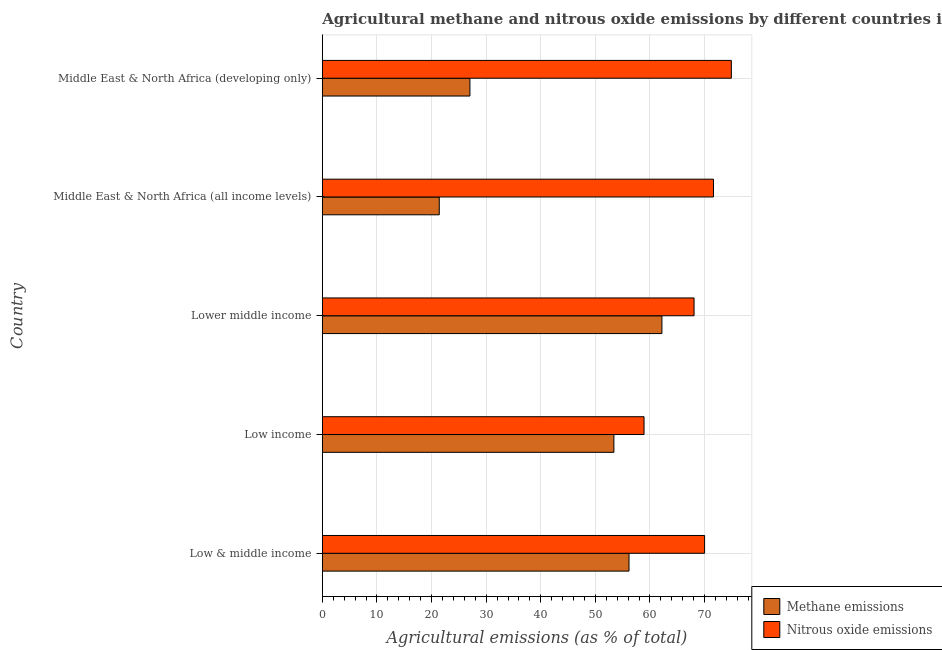How many groups of bars are there?
Provide a succinct answer. 5. How many bars are there on the 5th tick from the top?
Give a very brief answer. 2. How many bars are there on the 1st tick from the bottom?
Make the answer very short. 2. What is the label of the 4th group of bars from the top?
Ensure brevity in your answer.  Low income. What is the amount of methane emissions in Middle East & North Africa (all income levels)?
Provide a short and direct response. 21.41. Across all countries, what is the maximum amount of nitrous oxide emissions?
Offer a terse response. 74.9. Across all countries, what is the minimum amount of nitrous oxide emissions?
Your response must be concise. 58.91. In which country was the amount of nitrous oxide emissions maximum?
Your response must be concise. Middle East & North Africa (developing only). What is the total amount of nitrous oxide emissions in the graph?
Offer a very short reply. 343.5. What is the difference between the amount of nitrous oxide emissions in Low & middle income and that in Low income?
Keep it short and to the point. 11.09. What is the difference between the amount of methane emissions in Low & middle income and the amount of nitrous oxide emissions in Middle East & North Africa (developing only)?
Your answer should be very brief. -18.74. What is the average amount of nitrous oxide emissions per country?
Your answer should be compact. 68.7. What is the difference between the amount of nitrous oxide emissions and amount of methane emissions in Middle East & North Africa (developing only)?
Keep it short and to the point. 47.87. In how many countries, is the amount of methane emissions greater than 42 %?
Ensure brevity in your answer.  3. What is the ratio of the amount of nitrous oxide emissions in Low income to that in Middle East & North Africa (all income levels)?
Make the answer very short. 0.82. What is the difference between the highest and the second highest amount of methane emissions?
Give a very brief answer. 6.03. What is the difference between the highest and the lowest amount of methane emissions?
Keep it short and to the point. 40.77. In how many countries, is the amount of nitrous oxide emissions greater than the average amount of nitrous oxide emissions taken over all countries?
Your answer should be very brief. 3. Is the sum of the amount of methane emissions in Low & middle income and Middle East & North Africa (all income levels) greater than the maximum amount of nitrous oxide emissions across all countries?
Offer a terse response. Yes. What does the 2nd bar from the top in Lower middle income represents?
Your response must be concise. Methane emissions. What does the 2nd bar from the bottom in Lower middle income represents?
Offer a very short reply. Nitrous oxide emissions. What is the difference between two consecutive major ticks on the X-axis?
Give a very brief answer. 10. Are the values on the major ticks of X-axis written in scientific E-notation?
Your answer should be compact. No. Does the graph contain grids?
Your answer should be very brief. Yes. Where does the legend appear in the graph?
Offer a very short reply. Bottom right. What is the title of the graph?
Offer a very short reply. Agricultural methane and nitrous oxide emissions by different countries in 1990. Does "Time to import" appear as one of the legend labels in the graph?
Give a very brief answer. No. What is the label or title of the X-axis?
Make the answer very short. Agricultural emissions (as % of total). What is the label or title of the Y-axis?
Your response must be concise. Country. What is the Agricultural emissions (as % of total) of Methane emissions in Low & middle income?
Ensure brevity in your answer.  56.16. What is the Agricultural emissions (as % of total) in Nitrous oxide emissions in Low & middle income?
Ensure brevity in your answer.  70. What is the Agricultural emissions (as % of total) of Methane emissions in Low income?
Offer a very short reply. 53.39. What is the Agricultural emissions (as % of total) in Nitrous oxide emissions in Low income?
Keep it short and to the point. 58.91. What is the Agricultural emissions (as % of total) of Methane emissions in Lower middle income?
Your answer should be very brief. 62.18. What is the Agricultural emissions (as % of total) of Nitrous oxide emissions in Lower middle income?
Make the answer very short. 68.07. What is the Agricultural emissions (as % of total) of Methane emissions in Middle East & North Africa (all income levels)?
Offer a very short reply. 21.41. What is the Agricultural emissions (as % of total) of Nitrous oxide emissions in Middle East & North Africa (all income levels)?
Ensure brevity in your answer.  71.63. What is the Agricultural emissions (as % of total) in Methane emissions in Middle East & North Africa (developing only)?
Provide a succinct answer. 27.03. What is the Agricultural emissions (as % of total) in Nitrous oxide emissions in Middle East & North Africa (developing only)?
Offer a very short reply. 74.9. Across all countries, what is the maximum Agricultural emissions (as % of total) in Methane emissions?
Keep it short and to the point. 62.18. Across all countries, what is the maximum Agricultural emissions (as % of total) in Nitrous oxide emissions?
Ensure brevity in your answer.  74.9. Across all countries, what is the minimum Agricultural emissions (as % of total) of Methane emissions?
Keep it short and to the point. 21.41. Across all countries, what is the minimum Agricultural emissions (as % of total) in Nitrous oxide emissions?
Your response must be concise. 58.91. What is the total Agricultural emissions (as % of total) of Methane emissions in the graph?
Provide a short and direct response. 220.17. What is the total Agricultural emissions (as % of total) of Nitrous oxide emissions in the graph?
Ensure brevity in your answer.  343.5. What is the difference between the Agricultural emissions (as % of total) in Methane emissions in Low & middle income and that in Low income?
Ensure brevity in your answer.  2.77. What is the difference between the Agricultural emissions (as % of total) of Nitrous oxide emissions in Low & middle income and that in Low income?
Keep it short and to the point. 11.09. What is the difference between the Agricultural emissions (as % of total) in Methane emissions in Low & middle income and that in Lower middle income?
Keep it short and to the point. -6.03. What is the difference between the Agricultural emissions (as % of total) of Nitrous oxide emissions in Low & middle income and that in Lower middle income?
Your answer should be compact. 1.93. What is the difference between the Agricultural emissions (as % of total) of Methane emissions in Low & middle income and that in Middle East & North Africa (all income levels)?
Your response must be concise. 34.75. What is the difference between the Agricultural emissions (as % of total) of Nitrous oxide emissions in Low & middle income and that in Middle East & North Africa (all income levels)?
Keep it short and to the point. -1.63. What is the difference between the Agricultural emissions (as % of total) in Methane emissions in Low & middle income and that in Middle East & North Africa (developing only)?
Make the answer very short. 29.13. What is the difference between the Agricultural emissions (as % of total) of Nitrous oxide emissions in Low & middle income and that in Middle East & North Africa (developing only)?
Ensure brevity in your answer.  -4.9. What is the difference between the Agricultural emissions (as % of total) of Methane emissions in Low income and that in Lower middle income?
Provide a succinct answer. -8.8. What is the difference between the Agricultural emissions (as % of total) of Nitrous oxide emissions in Low income and that in Lower middle income?
Offer a very short reply. -9.16. What is the difference between the Agricultural emissions (as % of total) of Methane emissions in Low income and that in Middle East & North Africa (all income levels)?
Your response must be concise. 31.97. What is the difference between the Agricultural emissions (as % of total) in Nitrous oxide emissions in Low income and that in Middle East & North Africa (all income levels)?
Your answer should be very brief. -12.72. What is the difference between the Agricultural emissions (as % of total) of Methane emissions in Low income and that in Middle East & North Africa (developing only)?
Ensure brevity in your answer.  26.36. What is the difference between the Agricultural emissions (as % of total) in Nitrous oxide emissions in Low income and that in Middle East & North Africa (developing only)?
Make the answer very short. -15.98. What is the difference between the Agricultural emissions (as % of total) of Methane emissions in Lower middle income and that in Middle East & North Africa (all income levels)?
Your answer should be compact. 40.77. What is the difference between the Agricultural emissions (as % of total) in Nitrous oxide emissions in Lower middle income and that in Middle East & North Africa (all income levels)?
Your answer should be very brief. -3.56. What is the difference between the Agricultural emissions (as % of total) of Methane emissions in Lower middle income and that in Middle East & North Africa (developing only)?
Make the answer very short. 35.16. What is the difference between the Agricultural emissions (as % of total) of Nitrous oxide emissions in Lower middle income and that in Middle East & North Africa (developing only)?
Give a very brief answer. -6.83. What is the difference between the Agricultural emissions (as % of total) of Methane emissions in Middle East & North Africa (all income levels) and that in Middle East & North Africa (developing only)?
Ensure brevity in your answer.  -5.61. What is the difference between the Agricultural emissions (as % of total) in Nitrous oxide emissions in Middle East & North Africa (all income levels) and that in Middle East & North Africa (developing only)?
Keep it short and to the point. -3.27. What is the difference between the Agricultural emissions (as % of total) in Methane emissions in Low & middle income and the Agricultural emissions (as % of total) in Nitrous oxide emissions in Low income?
Make the answer very short. -2.75. What is the difference between the Agricultural emissions (as % of total) in Methane emissions in Low & middle income and the Agricultural emissions (as % of total) in Nitrous oxide emissions in Lower middle income?
Offer a very short reply. -11.91. What is the difference between the Agricultural emissions (as % of total) in Methane emissions in Low & middle income and the Agricultural emissions (as % of total) in Nitrous oxide emissions in Middle East & North Africa (all income levels)?
Keep it short and to the point. -15.47. What is the difference between the Agricultural emissions (as % of total) of Methane emissions in Low & middle income and the Agricultural emissions (as % of total) of Nitrous oxide emissions in Middle East & North Africa (developing only)?
Ensure brevity in your answer.  -18.74. What is the difference between the Agricultural emissions (as % of total) in Methane emissions in Low income and the Agricultural emissions (as % of total) in Nitrous oxide emissions in Lower middle income?
Your response must be concise. -14.68. What is the difference between the Agricultural emissions (as % of total) in Methane emissions in Low income and the Agricultural emissions (as % of total) in Nitrous oxide emissions in Middle East & North Africa (all income levels)?
Provide a succinct answer. -18.24. What is the difference between the Agricultural emissions (as % of total) in Methane emissions in Low income and the Agricultural emissions (as % of total) in Nitrous oxide emissions in Middle East & North Africa (developing only)?
Make the answer very short. -21.51. What is the difference between the Agricultural emissions (as % of total) of Methane emissions in Lower middle income and the Agricultural emissions (as % of total) of Nitrous oxide emissions in Middle East & North Africa (all income levels)?
Give a very brief answer. -9.44. What is the difference between the Agricultural emissions (as % of total) in Methane emissions in Lower middle income and the Agricultural emissions (as % of total) in Nitrous oxide emissions in Middle East & North Africa (developing only)?
Your response must be concise. -12.71. What is the difference between the Agricultural emissions (as % of total) of Methane emissions in Middle East & North Africa (all income levels) and the Agricultural emissions (as % of total) of Nitrous oxide emissions in Middle East & North Africa (developing only)?
Your answer should be very brief. -53.48. What is the average Agricultural emissions (as % of total) in Methane emissions per country?
Keep it short and to the point. 44.03. What is the average Agricultural emissions (as % of total) in Nitrous oxide emissions per country?
Your response must be concise. 68.7. What is the difference between the Agricultural emissions (as % of total) in Methane emissions and Agricultural emissions (as % of total) in Nitrous oxide emissions in Low & middle income?
Your answer should be compact. -13.84. What is the difference between the Agricultural emissions (as % of total) of Methane emissions and Agricultural emissions (as % of total) of Nitrous oxide emissions in Low income?
Offer a terse response. -5.52. What is the difference between the Agricultural emissions (as % of total) of Methane emissions and Agricultural emissions (as % of total) of Nitrous oxide emissions in Lower middle income?
Provide a succinct answer. -5.89. What is the difference between the Agricultural emissions (as % of total) in Methane emissions and Agricultural emissions (as % of total) in Nitrous oxide emissions in Middle East & North Africa (all income levels)?
Offer a very short reply. -50.22. What is the difference between the Agricultural emissions (as % of total) of Methane emissions and Agricultural emissions (as % of total) of Nitrous oxide emissions in Middle East & North Africa (developing only)?
Your response must be concise. -47.87. What is the ratio of the Agricultural emissions (as % of total) in Methane emissions in Low & middle income to that in Low income?
Keep it short and to the point. 1.05. What is the ratio of the Agricultural emissions (as % of total) of Nitrous oxide emissions in Low & middle income to that in Low income?
Offer a very short reply. 1.19. What is the ratio of the Agricultural emissions (as % of total) of Methane emissions in Low & middle income to that in Lower middle income?
Offer a terse response. 0.9. What is the ratio of the Agricultural emissions (as % of total) of Nitrous oxide emissions in Low & middle income to that in Lower middle income?
Your answer should be very brief. 1.03. What is the ratio of the Agricultural emissions (as % of total) of Methane emissions in Low & middle income to that in Middle East & North Africa (all income levels)?
Your answer should be compact. 2.62. What is the ratio of the Agricultural emissions (as % of total) of Nitrous oxide emissions in Low & middle income to that in Middle East & North Africa (all income levels)?
Offer a terse response. 0.98. What is the ratio of the Agricultural emissions (as % of total) in Methane emissions in Low & middle income to that in Middle East & North Africa (developing only)?
Your answer should be compact. 2.08. What is the ratio of the Agricultural emissions (as % of total) in Nitrous oxide emissions in Low & middle income to that in Middle East & North Africa (developing only)?
Provide a succinct answer. 0.93. What is the ratio of the Agricultural emissions (as % of total) of Methane emissions in Low income to that in Lower middle income?
Give a very brief answer. 0.86. What is the ratio of the Agricultural emissions (as % of total) of Nitrous oxide emissions in Low income to that in Lower middle income?
Ensure brevity in your answer.  0.87. What is the ratio of the Agricultural emissions (as % of total) in Methane emissions in Low income to that in Middle East & North Africa (all income levels)?
Give a very brief answer. 2.49. What is the ratio of the Agricultural emissions (as % of total) in Nitrous oxide emissions in Low income to that in Middle East & North Africa (all income levels)?
Provide a short and direct response. 0.82. What is the ratio of the Agricultural emissions (as % of total) in Methane emissions in Low income to that in Middle East & North Africa (developing only)?
Ensure brevity in your answer.  1.98. What is the ratio of the Agricultural emissions (as % of total) in Nitrous oxide emissions in Low income to that in Middle East & North Africa (developing only)?
Ensure brevity in your answer.  0.79. What is the ratio of the Agricultural emissions (as % of total) in Methane emissions in Lower middle income to that in Middle East & North Africa (all income levels)?
Keep it short and to the point. 2.9. What is the ratio of the Agricultural emissions (as % of total) in Nitrous oxide emissions in Lower middle income to that in Middle East & North Africa (all income levels)?
Keep it short and to the point. 0.95. What is the ratio of the Agricultural emissions (as % of total) in Methane emissions in Lower middle income to that in Middle East & North Africa (developing only)?
Make the answer very short. 2.3. What is the ratio of the Agricultural emissions (as % of total) of Nitrous oxide emissions in Lower middle income to that in Middle East & North Africa (developing only)?
Your answer should be compact. 0.91. What is the ratio of the Agricultural emissions (as % of total) in Methane emissions in Middle East & North Africa (all income levels) to that in Middle East & North Africa (developing only)?
Offer a terse response. 0.79. What is the ratio of the Agricultural emissions (as % of total) of Nitrous oxide emissions in Middle East & North Africa (all income levels) to that in Middle East & North Africa (developing only)?
Ensure brevity in your answer.  0.96. What is the difference between the highest and the second highest Agricultural emissions (as % of total) in Methane emissions?
Give a very brief answer. 6.03. What is the difference between the highest and the second highest Agricultural emissions (as % of total) in Nitrous oxide emissions?
Provide a succinct answer. 3.27. What is the difference between the highest and the lowest Agricultural emissions (as % of total) of Methane emissions?
Ensure brevity in your answer.  40.77. What is the difference between the highest and the lowest Agricultural emissions (as % of total) of Nitrous oxide emissions?
Give a very brief answer. 15.98. 